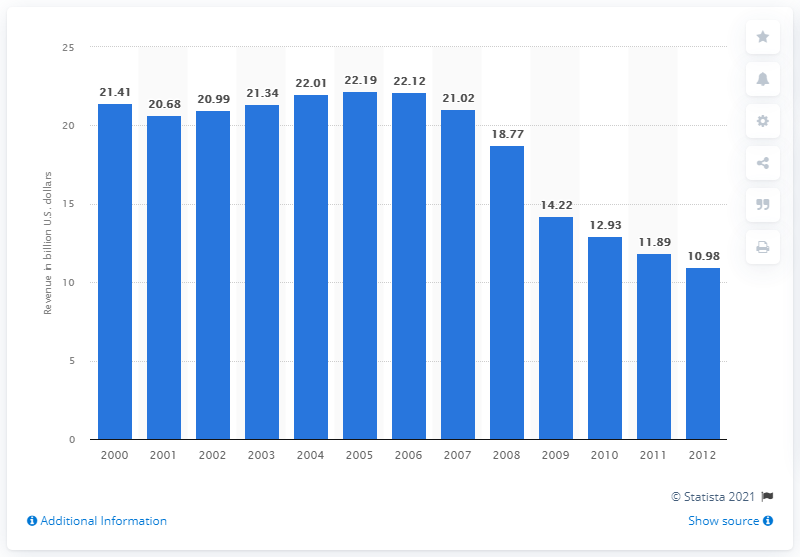Mention a couple of crucial points in this snapshot. In 2010, the retail advertising revenue of U.S. newspapers was 12.93. 